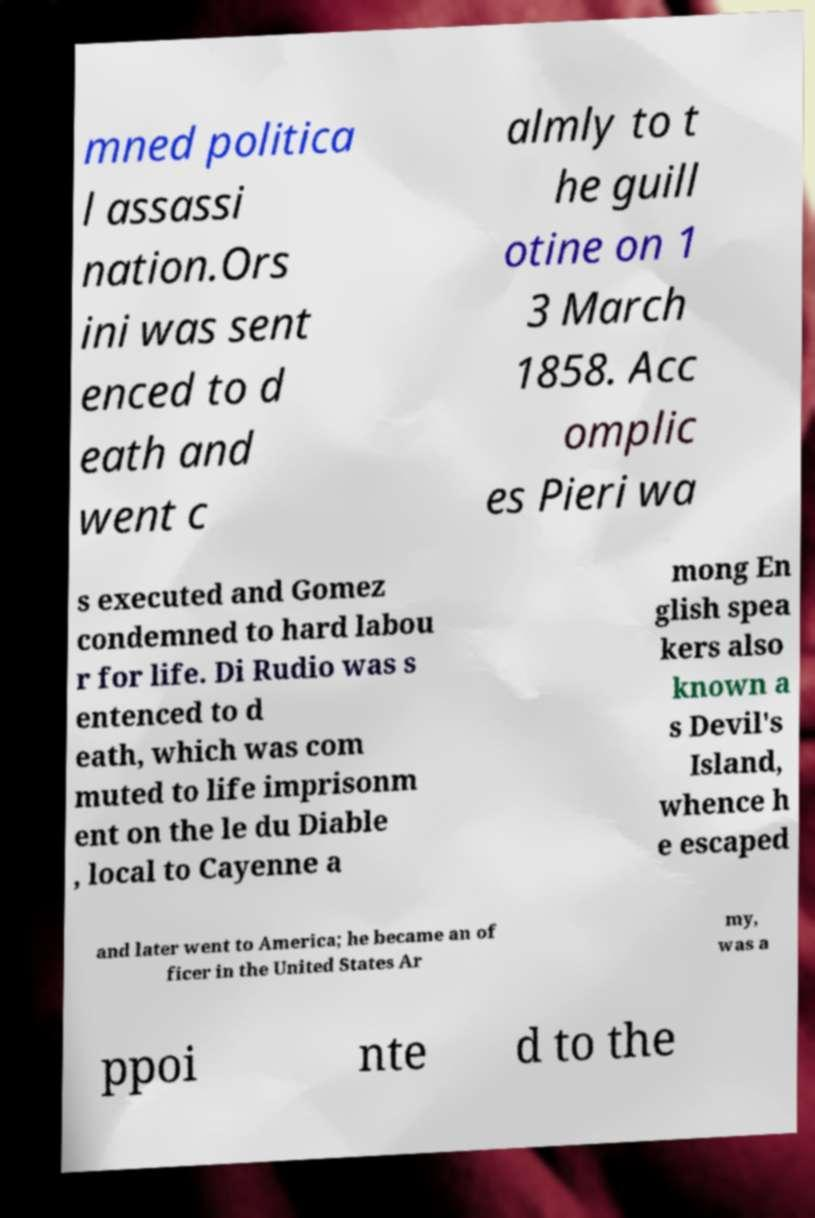What messages or text are displayed in this image? I need them in a readable, typed format. mned politica l assassi nation.Ors ini was sent enced to d eath and went c almly to t he guill otine on 1 3 March 1858. Acc omplic es Pieri wa s executed and Gomez condemned to hard labou r for life. Di Rudio was s entenced to d eath, which was com muted to life imprisonm ent on the le du Diable , local to Cayenne a mong En glish spea kers also known a s Devil's Island, whence h e escaped and later went to America; he became an of ficer in the United States Ar my, was a ppoi nte d to the 